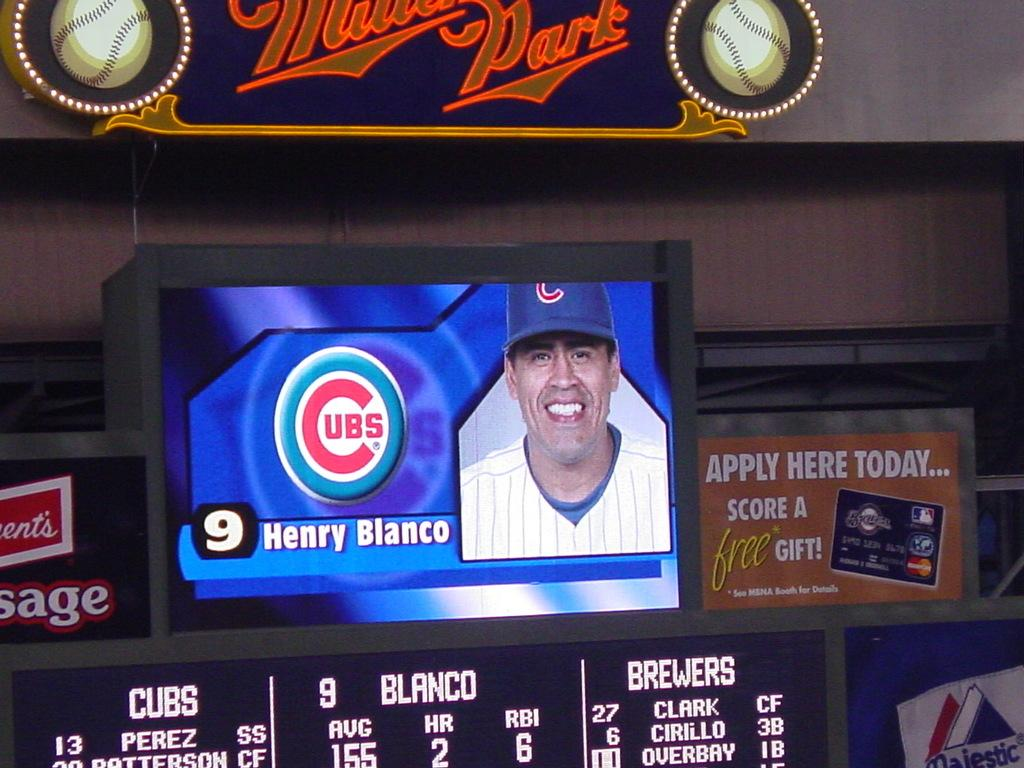<image>
Summarize the visual content of the image. a screen showing a baseball player named Henry Blanco. 